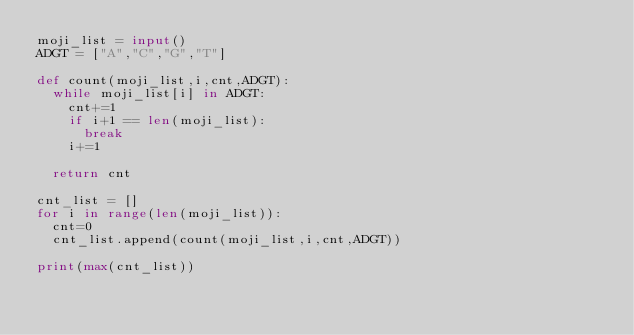Convert code to text. <code><loc_0><loc_0><loc_500><loc_500><_Python_>moji_list = input()
ADGT = ["A","C","G","T"]

def count(moji_list,i,cnt,ADGT):
  while moji_list[i] in ADGT:
    cnt+=1
    if i+1 == len(moji_list):
      break
    i+=1
    
  return cnt

cnt_list = []
for i in range(len(moji_list)):
  cnt=0
  cnt_list.append(count(moji_list,i,cnt,ADGT))
  
print(max(cnt_list))</code> 